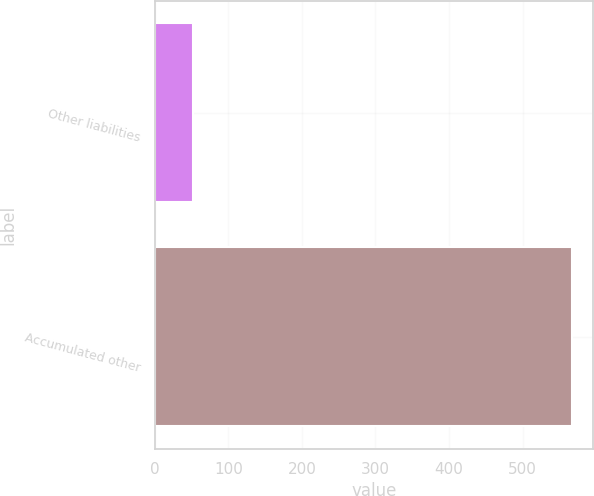<chart> <loc_0><loc_0><loc_500><loc_500><bar_chart><fcel>Other liabilities<fcel>Accumulated other<nl><fcel>52<fcel>567<nl></chart> 